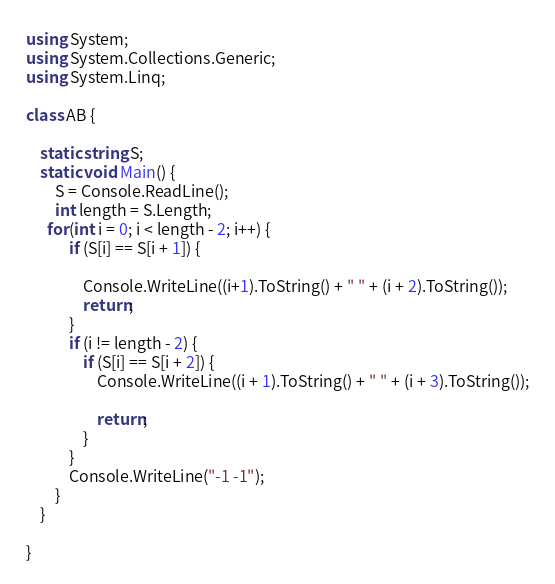<code> <loc_0><loc_0><loc_500><loc_500><_C#_>using System;
using System.Collections.Generic;
using System.Linq;

class AB {

    static string S;
    static void Main() {
        S = Console.ReadLine();
        int length = S.Length;
      for(int i = 0; i < length - 2; i++) {
            if (S[i] == S[i + 1]) {
                
                Console.WriteLine((i+1).ToString() + " " + (i + 2).ToString());
                return;
            }
            if (i != length - 2) {
                if (S[i] == S[i + 2]) {
                    Console.WriteLine((i + 1).ToString() + " " + (i + 3).ToString());

                    return;
                }
            }
            Console.WriteLine("-1 -1");
        }
    }
   
}


</code> 